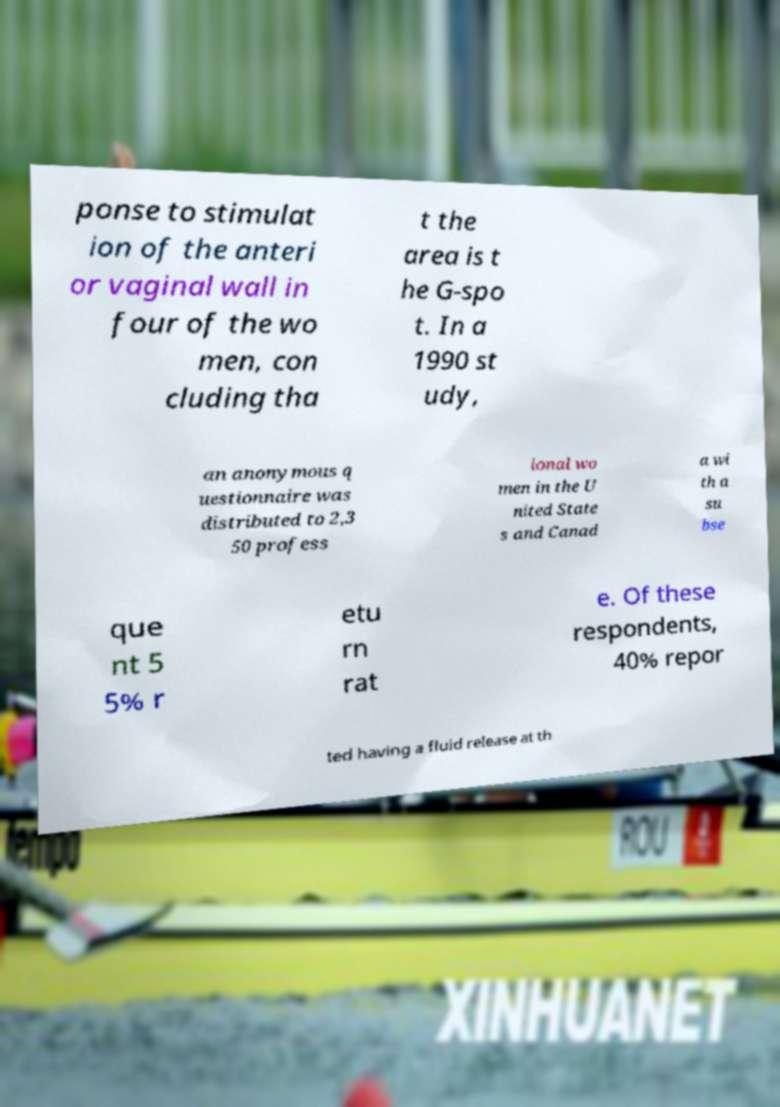Can you accurately transcribe the text from the provided image for me? ponse to stimulat ion of the anteri or vaginal wall in four of the wo men, con cluding tha t the area is t he G-spo t. In a 1990 st udy, an anonymous q uestionnaire was distributed to 2,3 50 profess ional wo men in the U nited State s and Canad a wi th a su bse que nt 5 5% r etu rn rat e. Of these respondents, 40% repor ted having a fluid release at th 